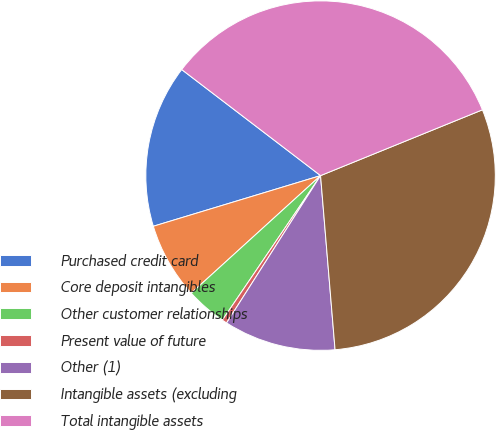Convert chart. <chart><loc_0><loc_0><loc_500><loc_500><pie_chart><fcel>Purchased credit card<fcel>Core deposit intangibles<fcel>Other customer relationships<fcel>Present value of future<fcel>Other (1)<fcel>Intangible assets (excluding<fcel>Total intangible assets<nl><fcel>15.06%<fcel>7.06%<fcel>3.76%<fcel>0.46%<fcel>10.36%<fcel>29.82%<fcel>33.47%<nl></chart> 